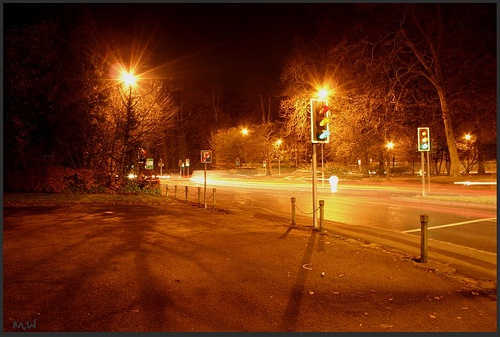Describe the objects in this image and their specific colors. I can see traffic light in black, red, maroon, orange, and beige tones and traffic light in black, khaki, red, beige, and brown tones in this image. 